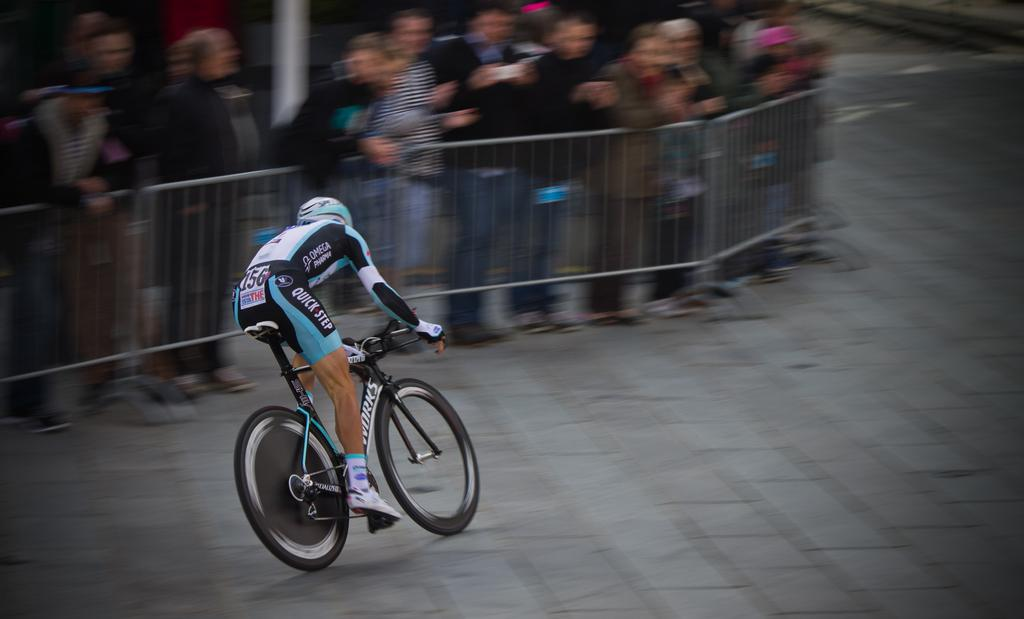What is the main activity taking place in the image? There is a person riding a bicycle in the image, and they are participating in a race. What can be seen on the left side of the image? There is a fencing on the left side of the image. What are the people behind the fencing doing? People are standing behind the fencing and watching the race. What type of pen is the person riding a bicycle using to write their name on the race track? There is no pen present in the image, and the person riding a bicycle is not writing their name on the race track. 